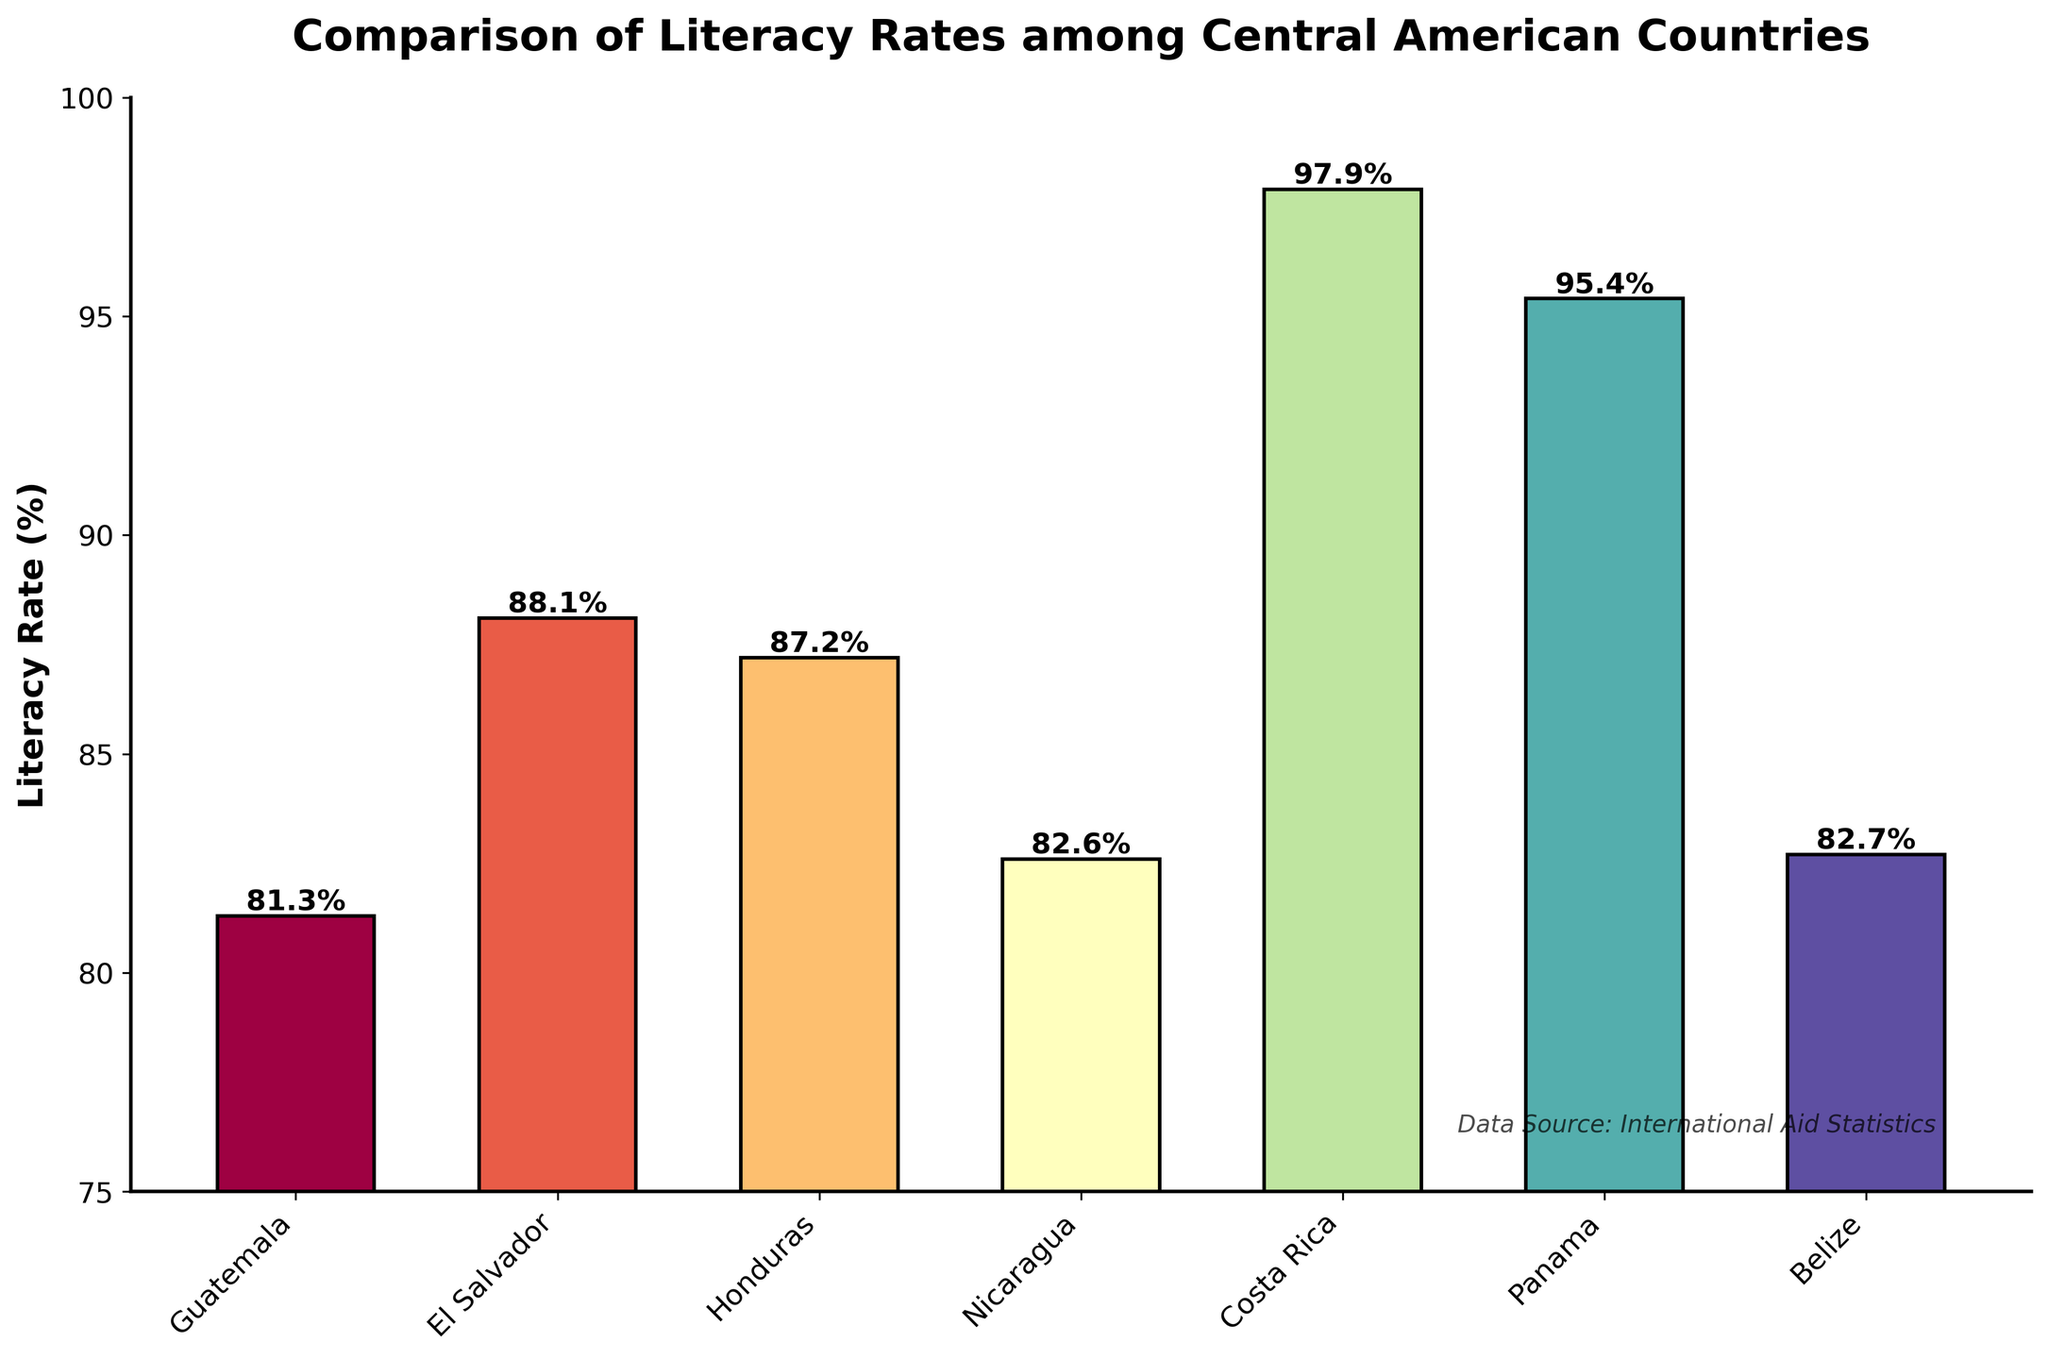Which country has the highest literacy rate? By looking at the top of the bars in the figure, Costa Rica has the tallest bar, indicating it has the highest literacy rate.
Answer: Costa Rica Which country has the lowest literacy rate? By observing the figure, Guatemala has the shortest bar, indicating it has the lowest literacy rate.
Answer: Guatemala What is the average literacy rate of all the Central American countries shown? Sum all the literacy rates (81.3 + 88.1 + 87.2 + 82.6 + 97.9 + 95.4 + 82.7) to get a total of 615.2. Then, divide by the number of countries (7): 615.2 / 7 ≈ 87.9%.
Answer: 87.9% How much higher is Panama's literacy rate compared to Guatemala's? Panama’s literacy rate is 95.4%, and Guatemala’s is 81.3%. The difference is 95.4 - 81.3 = 14.1%.
Answer: 14.1% Rank the countries from highest to lowest literacy rates. By comparing the height of the bars from tallest to shortest, the ranking is: Costa Rica, Panama, El Salvador, Honduras, Belize, Nicaragua, Guatemala.
Answer: Costa Rica, Panama, El Salvador, Honduras, Belize, Nicaragua, Guatemala What is the median literacy rate of these countries? The sorted literacy rates are: 81.3, 82.6, 82.7, 87.2, 88.1, 95.4, 97.9. The median, being the middle value, is 87.2% (Honduras).
Answer: 87.2% By how much does Nicaragua's literacy rate differ from that of Belize? Nicaragua's literacy rate is 82.6%, and Belize’s is 82.7%. The difference is 82.7 - 82.6 = 0.1%.
Answer: 0.1% Which countries have a literacy rate above the average literacy rate? The average literacy rate is about 87.9%. Countries with rates above this average are Costa Rica, Panama, and El Salvador.
Answer: Costa Rica, Panama, El Salvador What is the combined literacy rate of Honduras, Nicaragua, and Belize? Sum the literacy rates of Honduras (87.2%), Nicaragua (82.6%), and Belize (82.7%): 87.2 + 82.6 + 82.7 = 252.5%.
Answer: 252.5% What is the difference between the highest and the lowest literacy rates displayed? The highest literacy rate is Costa Rica’s at 97.9%, and the lowest is Guatemala’s at 81.3%. The difference is 97.9 - 81.3 = 16.6%.
Answer: 16.6% 